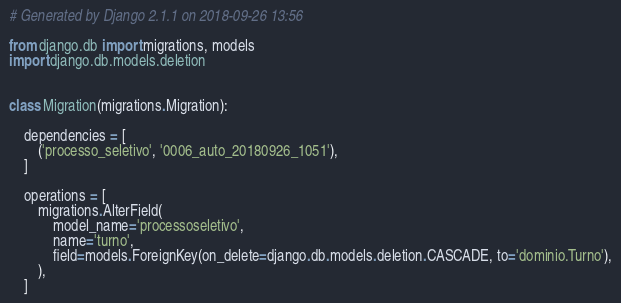<code> <loc_0><loc_0><loc_500><loc_500><_Python_># Generated by Django 2.1.1 on 2018-09-26 13:56

from django.db import migrations, models
import django.db.models.deletion


class Migration(migrations.Migration):

    dependencies = [
        ('processo_seletivo', '0006_auto_20180926_1051'),
    ]

    operations = [
        migrations.AlterField(
            model_name='processoseletivo',
            name='turno',
            field=models.ForeignKey(on_delete=django.db.models.deletion.CASCADE, to='dominio.Turno'),
        ),
    ]
</code> 